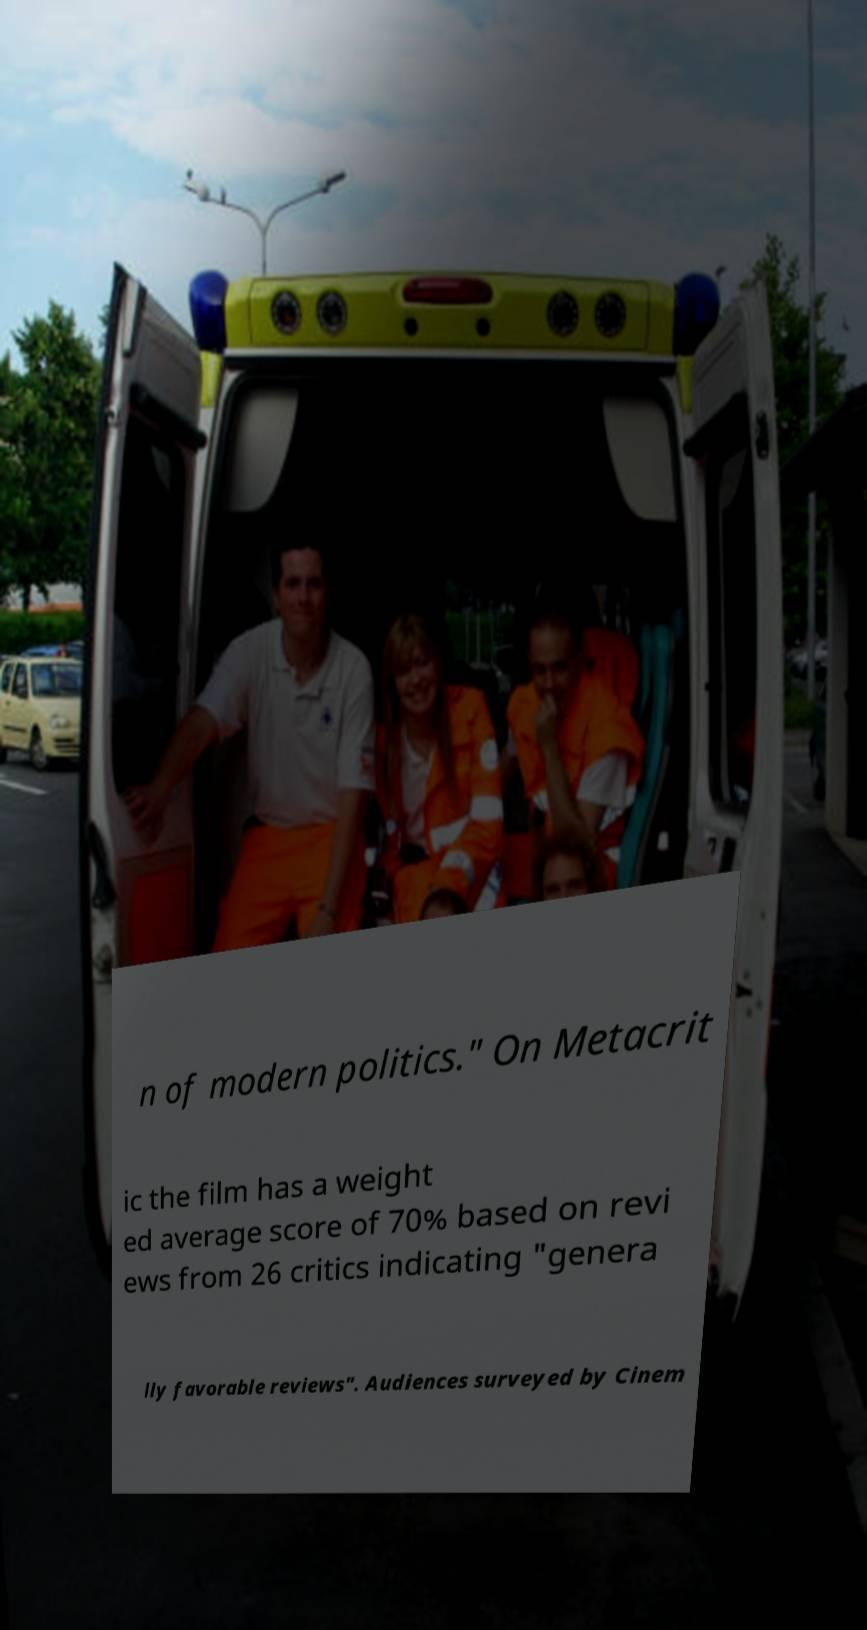Can you read and provide the text displayed in the image?This photo seems to have some interesting text. Can you extract and type it out for me? n of modern politics." On Metacrit ic the film has a weight ed average score of 70% based on revi ews from 26 critics indicating "genera lly favorable reviews". Audiences surveyed by Cinem 